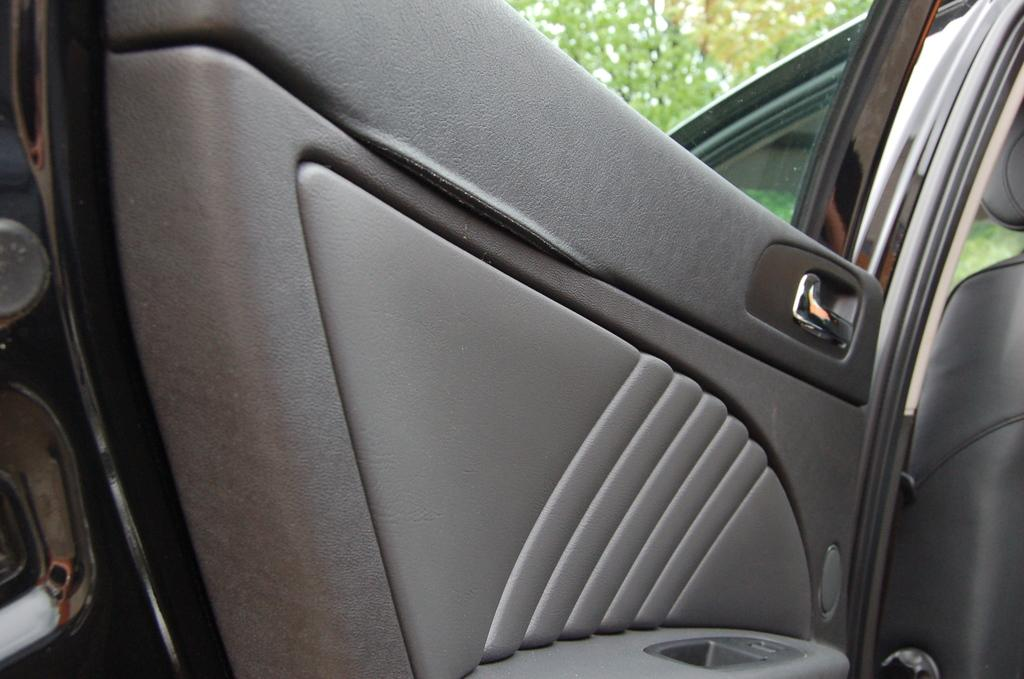Where was the image taken? The image was taken outside a car. What is the main subject of the image? There is a car in the center of the image. What can be seen in the background of the image? There are trees visible in the image. What type of news can be seen on the car's windshield in the image? There is no news visible on the car's windshield in the image. What type of property is visible in the image? The image does not show any specific property; it only features a car and trees. 